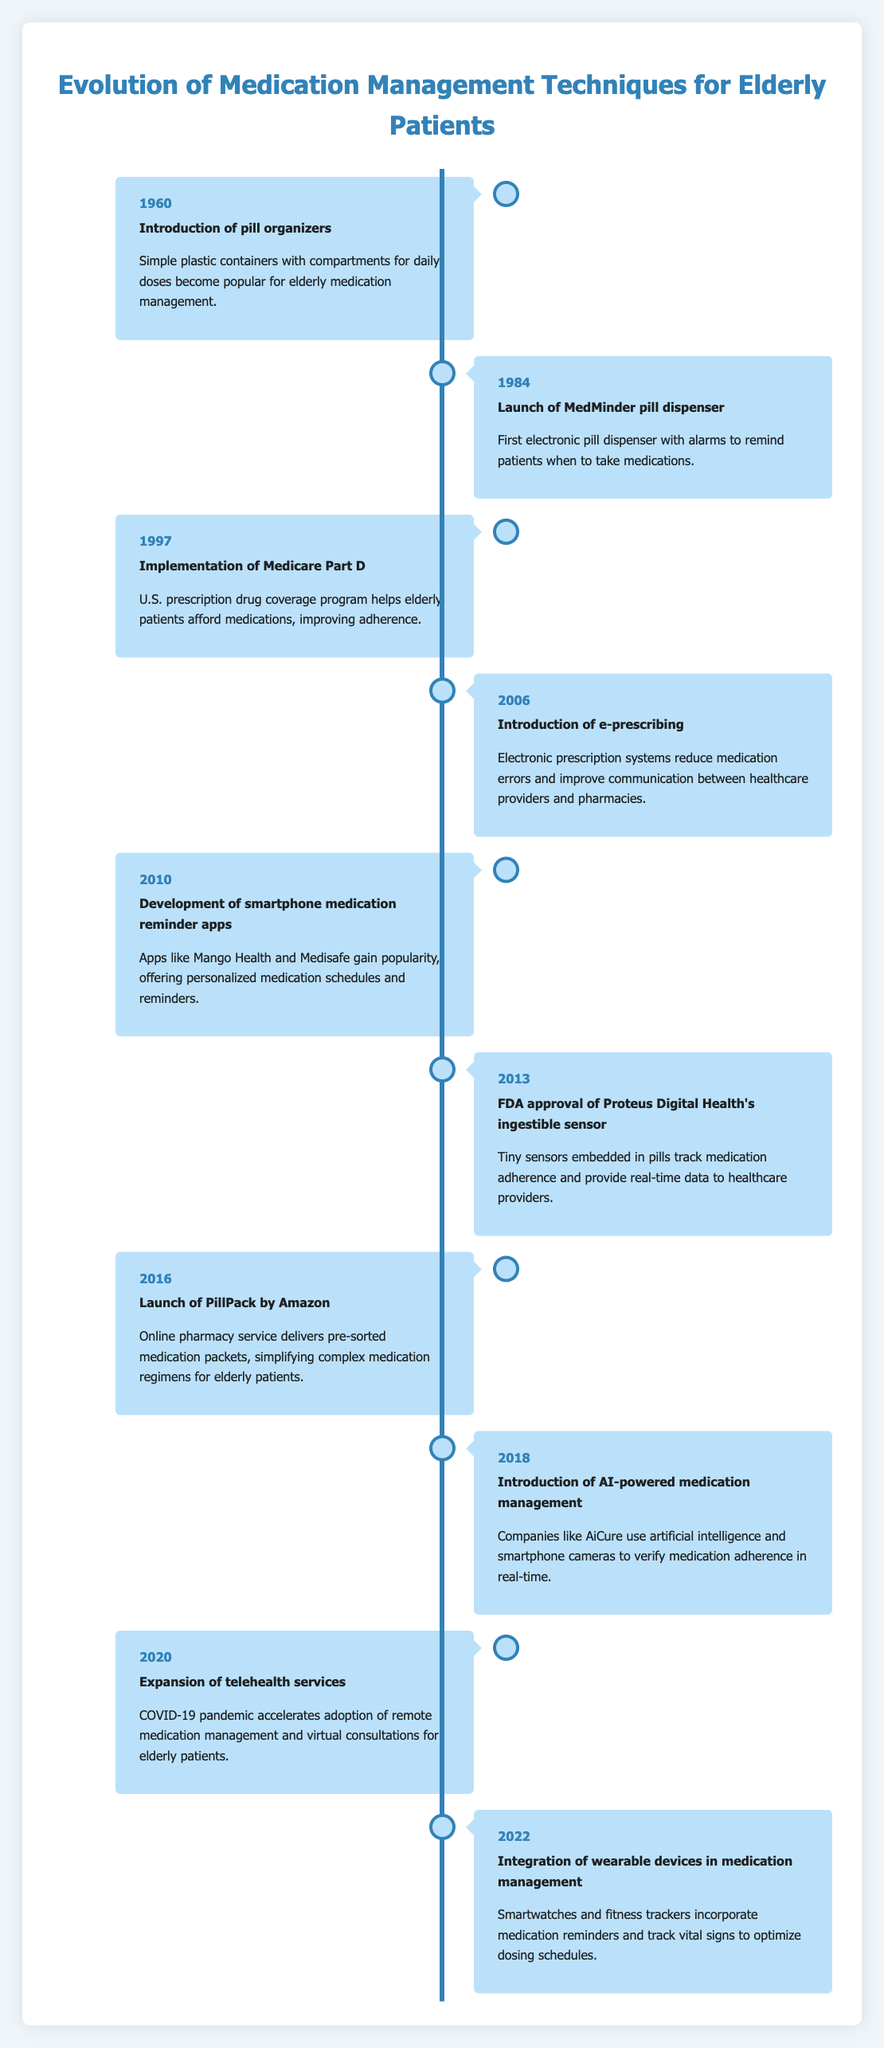What was the first medication management technique introduced for elderly patients? The table indicates that the first event listed is from 1960, which is the "Introduction of pill organizers." This was a simple container designed to help manage daily doses for elderly patients.
Answer: Introduction of pill organizers How many years passed between the launch of the MedMinder pill dispenser and the implementation of Medicare Part D? The MedMinder pill dispenser was launched in 1984, and Medicare Part D was implemented in 1997. The difference is 1997 - 1984 = 13 years.
Answer: 13 years Is the introduction of e-prescribing earlier than the launch of PillPack by Amazon? According to the timeline, e-prescribing was introduced in 2006, and PillPack was launched in 2016. Since 2006 is earlier than 2016, the answer is yes.
Answer: Yes What is the average year of introduction for the medication management techniques listed in the table? The relevant years are 1960, 1984, 1997, 2006, 2010, 2013, 2016, 2018, 2020, and 2022. Adding them gives a total of 1960 + 1984 + 1997 + 2006 + 2010 + 2013 + 2016 + 2018 + 2020 + 2022 = 19988. There are 10 techniques, so the average is 19988 / 10 = 1998.8, which rounds to 1999.
Answer: 1999 How many events mentioned in the table occurred after 2015? The events after 2015 are from the years 2016, 2018, 2020, and 2022. Counting these gives a total of 4 events.
Answer: 4 events Which technique was introduced in 2018, and what was its key feature? Looking at the table, the technique introduced in 2018 is the "Introduction of AI-powered medication management," and its key feature includes using artificial intelligence and smartphone cameras to verify medication adherence in real-time.
Answer: Introduction of AI-powered medication management; using AI and smartphone cameras for adherence verification 